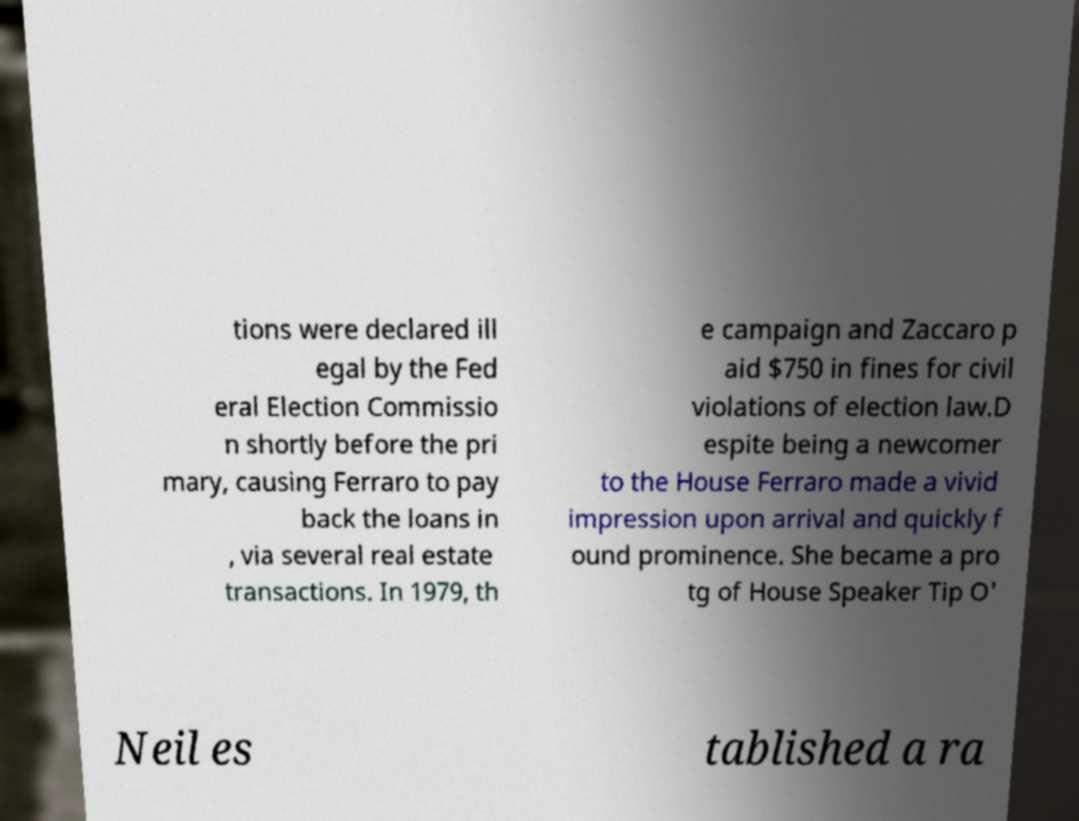Can you accurately transcribe the text from the provided image for me? tions were declared ill egal by the Fed eral Election Commissio n shortly before the pri mary, causing Ferraro to pay back the loans in , via several real estate transactions. In 1979, th e campaign and Zaccaro p aid $750 in fines for civil violations of election law.D espite being a newcomer to the House Ferraro made a vivid impression upon arrival and quickly f ound prominence. She became a pro tg of House Speaker Tip O' Neil es tablished a ra 